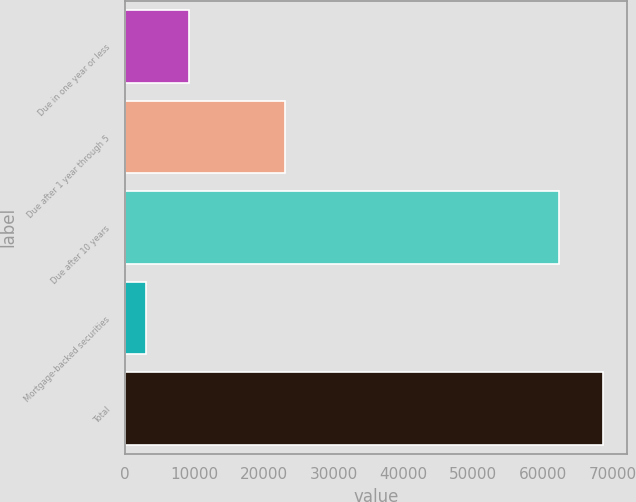Convert chart to OTSL. <chart><loc_0><loc_0><loc_500><loc_500><bar_chart><fcel>Due in one year or less<fcel>Due after 1 year through 5<fcel>Due after 10 years<fcel>Mortgage-backed securities<fcel>Total<nl><fcel>9236.6<fcel>22944<fcel>62396<fcel>2997<fcel>68635.6<nl></chart> 